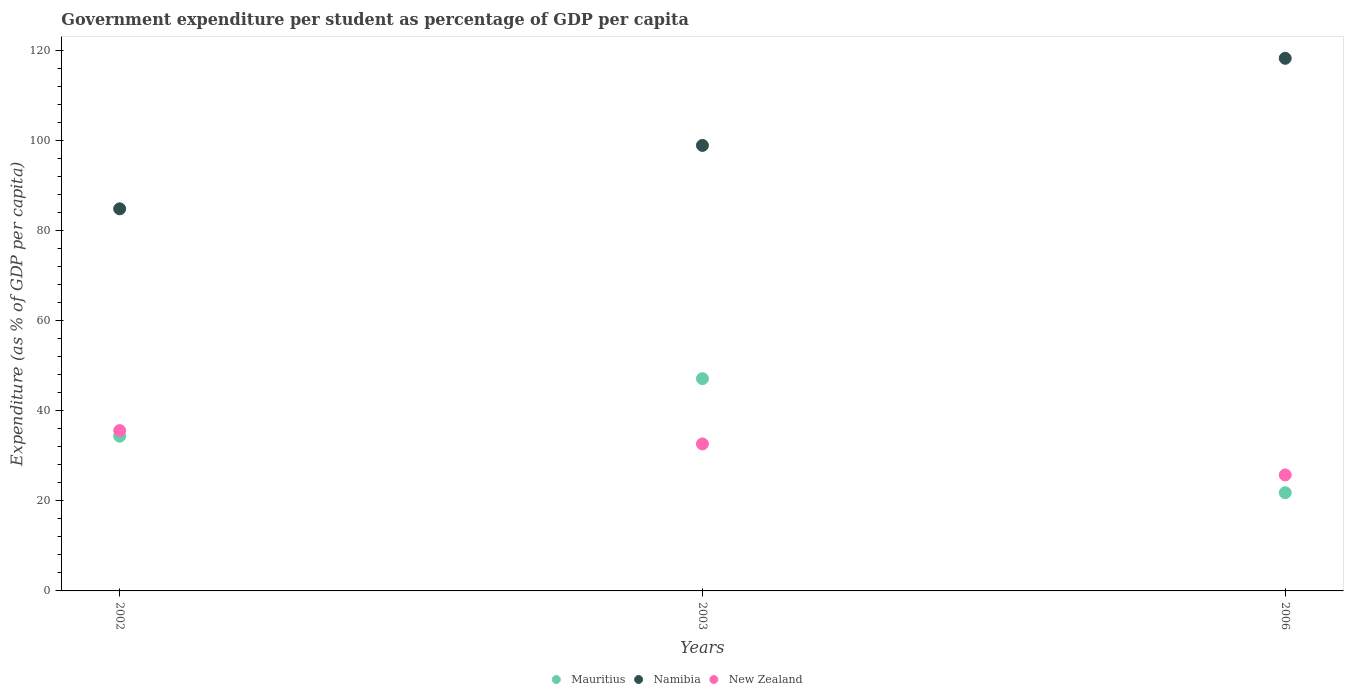How many different coloured dotlines are there?
Offer a terse response. 3. Is the number of dotlines equal to the number of legend labels?
Give a very brief answer. Yes. What is the percentage of expenditure per student in Mauritius in 2006?
Provide a succinct answer. 21.8. Across all years, what is the maximum percentage of expenditure per student in Namibia?
Give a very brief answer. 118.22. Across all years, what is the minimum percentage of expenditure per student in Namibia?
Your response must be concise. 84.81. In which year was the percentage of expenditure per student in Mauritius maximum?
Give a very brief answer. 2003. What is the total percentage of expenditure per student in New Zealand in the graph?
Make the answer very short. 93.96. What is the difference between the percentage of expenditure per student in New Zealand in 2003 and that in 2006?
Ensure brevity in your answer.  6.88. What is the difference between the percentage of expenditure per student in Mauritius in 2002 and the percentage of expenditure per student in Namibia in 2003?
Ensure brevity in your answer.  -64.53. What is the average percentage of expenditure per student in Mauritius per year?
Provide a succinct answer. 34.42. In the year 2003, what is the difference between the percentage of expenditure per student in New Zealand and percentage of expenditure per student in Mauritius?
Your answer should be compact. -14.48. In how many years, is the percentage of expenditure per student in Namibia greater than 44 %?
Make the answer very short. 3. What is the ratio of the percentage of expenditure per student in New Zealand in 2002 to that in 2006?
Make the answer very short. 1.38. Is the percentage of expenditure per student in Mauritius in 2002 less than that in 2003?
Your answer should be very brief. Yes. What is the difference between the highest and the second highest percentage of expenditure per student in Namibia?
Offer a terse response. 19.34. What is the difference between the highest and the lowest percentage of expenditure per student in Mauritius?
Offer a terse response. 25.31. In how many years, is the percentage of expenditure per student in Mauritius greater than the average percentage of expenditure per student in Mauritius taken over all years?
Your answer should be very brief. 1. Is the percentage of expenditure per student in New Zealand strictly greater than the percentage of expenditure per student in Mauritius over the years?
Give a very brief answer. No. Is the percentage of expenditure per student in Mauritius strictly less than the percentage of expenditure per student in Namibia over the years?
Ensure brevity in your answer.  Yes. How many dotlines are there?
Offer a very short reply. 3. How many years are there in the graph?
Offer a very short reply. 3. Does the graph contain any zero values?
Offer a very short reply. No. Does the graph contain grids?
Your answer should be very brief. No. Where does the legend appear in the graph?
Provide a short and direct response. Bottom center. How many legend labels are there?
Your answer should be compact. 3. How are the legend labels stacked?
Your answer should be compact. Horizontal. What is the title of the graph?
Your response must be concise. Government expenditure per student as percentage of GDP per capita. Does "Ukraine" appear as one of the legend labels in the graph?
Your response must be concise. No. What is the label or title of the Y-axis?
Provide a succinct answer. Expenditure (as % of GDP per capita). What is the Expenditure (as % of GDP per capita) of Mauritius in 2002?
Your answer should be compact. 34.35. What is the Expenditure (as % of GDP per capita) in Namibia in 2002?
Offer a very short reply. 84.81. What is the Expenditure (as % of GDP per capita) of New Zealand in 2002?
Give a very brief answer. 35.58. What is the Expenditure (as % of GDP per capita) of Mauritius in 2003?
Give a very brief answer. 47.11. What is the Expenditure (as % of GDP per capita) in Namibia in 2003?
Offer a terse response. 98.88. What is the Expenditure (as % of GDP per capita) in New Zealand in 2003?
Offer a terse response. 32.63. What is the Expenditure (as % of GDP per capita) of Mauritius in 2006?
Offer a terse response. 21.8. What is the Expenditure (as % of GDP per capita) of Namibia in 2006?
Your response must be concise. 118.22. What is the Expenditure (as % of GDP per capita) of New Zealand in 2006?
Ensure brevity in your answer.  25.75. Across all years, what is the maximum Expenditure (as % of GDP per capita) of Mauritius?
Offer a terse response. 47.11. Across all years, what is the maximum Expenditure (as % of GDP per capita) in Namibia?
Keep it short and to the point. 118.22. Across all years, what is the maximum Expenditure (as % of GDP per capita) in New Zealand?
Your answer should be compact. 35.58. Across all years, what is the minimum Expenditure (as % of GDP per capita) of Mauritius?
Provide a succinct answer. 21.8. Across all years, what is the minimum Expenditure (as % of GDP per capita) of Namibia?
Offer a terse response. 84.81. Across all years, what is the minimum Expenditure (as % of GDP per capita) in New Zealand?
Your answer should be very brief. 25.75. What is the total Expenditure (as % of GDP per capita) in Mauritius in the graph?
Keep it short and to the point. 103.26. What is the total Expenditure (as % of GDP per capita) in Namibia in the graph?
Offer a very short reply. 301.9. What is the total Expenditure (as % of GDP per capita) of New Zealand in the graph?
Provide a short and direct response. 93.96. What is the difference between the Expenditure (as % of GDP per capita) in Mauritius in 2002 and that in 2003?
Your response must be concise. -12.76. What is the difference between the Expenditure (as % of GDP per capita) in Namibia in 2002 and that in 2003?
Make the answer very short. -14.07. What is the difference between the Expenditure (as % of GDP per capita) in New Zealand in 2002 and that in 2003?
Make the answer very short. 2.96. What is the difference between the Expenditure (as % of GDP per capita) in Mauritius in 2002 and that in 2006?
Offer a very short reply. 12.55. What is the difference between the Expenditure (as % of GDP per capita) in Namibia in 2002 and that in 2006?
Offer a very short reply. -33.41. What is the difference between the Expenditure (as % of GDP per capita) in New Zealand in 2002 and that in 2006?
Offer a very short reply. 9.84. What is the difference between the Expenditure (as % of GDP per capita) in Mauritius in 2003 and that in 2006?
Your answer should be compact. 25.31. What is the difference between the Expenditure (as % of GDP per capita) of Namibia in 2003 and that in 2006?
Keep it short and to the point. -19.34. What is the difference between the Expenditure (as % of GDP per capita) in New Zealand in 2003 and that in 2006?
Your response must be concise. 6.88. What is the difference between the Expenditure (as % of GDP per capita) in Mauritius in 2002 and the Expenditure (as % of GDP per capita) in Namibia in 2003?
Provide a succinct answer. -64.53. What is the difference between the Expenditure (as % of GDP per capita) in Mauritius in 2002 and the Expenditure (as % of GDP per capita) in New Zealand in 2003?
Give a very brief answer. 1.72. What is the difference between the Expenditure (as % of GDP per capita) in Namibia in 2002 and the Expenditure (as % of GDP per capita) in New Zealand in 2003?
Keep it short and to the point. 52.18. What is the difference between the Expenditure (as % of GDP per capita) of Mauritius in 2002 and the Expenditure (as % of GDP per capita) of Namibia in 2006?
Offer a terse response. -83.87. What is the difference between the Expenditure (as % of GDP per capita) in Mauritius in 2002 and the Expenditure (as % of GDP per capita) in New Zealand in 2006?
Ensure brevity in your answer.  8.6. What is the difference between the Expenditure (as % of GDP per capita) in Namibia in 2002 and the Expenditure (as % of GDP per capita) in New Zealand in 2006?
Offer a terse response. 59.06. What is the difference between the Expenditure (as % of GDP per capita) in Mauritius in 2003 and the Expenditure (as % of GDP per capita) in Namibia in 2006?
Offer a very short reply. -71.11. What is the difference between the Expenditure (as % of GDP per capita) in Mauritius in 2003 and the Expenditure (as % of GDP per capita) in New Zealand in 2006?
Provide a succinct answer. 21.36. What is the difference between the Expenditure (as % of GDP per capita) of Namibia in 2003 and the Expenditure (as % of GDP per capita) of New Zealand in 2006?
Offer a very short reply. 73.13. What is the average Expenditure (as % of GDP per capita) in Mauritius per year?
Provide a short and direct response. 34.42. What is the average Expenditure (as % of GDP per capita) in Namibia per year?
Offer a very short reply. 100.63. What is the average Expenditure (as % of GDP per capita) of New Zealand per year?
Keep it short and to the point. 31.32. In the year 2002, what is the difference between the Expenditure (as % of GDP per capita) of Mauritius and Expenditure (as % of GDP per capita) of Namibia?
Provide a short and direct response. -50.46. In the year 2002, what is the difference between the Expenditure (as % of GDP per capita) of Mauritius and Expenditure (as % of GDP per capita) of New Zealand?
Your answer should be very brief. -1.23. In the year 2002, what is the difference between the Expenditure (as % of GDP per capita) of Namibia and Expenditure (as % of GDP per capita) of New Zealand?
Provide a short and direct response. 49.23. In the year 2003, what is the difference between the Expenditure (as % of GDP per capita) in Mauritius and Expenditure (as % of GDP per capita) in Namibia?
Provide a succinct answer. -51.77. In the year 2003, what is the difference between the Expenditure (as % of GDP per capita) of Mauritius and Expenditure (as % of GDP per capita) of New Zealand?
Your answer should be compact. 14.48. In the year 2003, what is the difference between the Expenditure (as % of GDP per capita) of Namibia and Expenditure (as % of GDP per capita) of New Zealand?
Offer a terse response. 66.25. In the year 2006, what is the difference between the Expenditure (as % of GDP per capita) in Mauritius and Expenditure (as % of GDP per capita) in Namibia?
Provide a succinct answer. -96.42. In the year 2006, what is the difference between the Expenditure (as % of GDP per capita) in Mauritius and Expenditure (as % of GDP per capita) in New Zealand?
Offer a terse response. -3.95. In the year 2006, what is the difference between the Expenditure (as % of GDP per capita) in Namibia and Expenditure (as % of GDP per capita) in New Zealand?
Provide a short and direct response. 92.47. What is the ratio of the Expenditure (as % of GDP per capita) of Mauritius in 2002 to that in 2003?
Offer a terse response. 0.73. What is the ratio of the Expenditure (as % of GDP per capita) of Namibia in 2002 to that in 2003?
Keep it short and to the point. 0.86. What is the ratio of the Expenditure (as % of GDP per capita) in New Zealand in 2002 to that in 2003?
Provide a succinct answer. 1.09. What is the ratio of the Expenditure (as % of GDP per capita) of Mauritius in 2002 to that in 2006?
Provide a succinct answer. 1.58. What is the ratio of the Expenditure (as % of GDP per capita) of Namibia in 2002 to that in 2006?
Offer a terse response. 0.72. What is the ratio of the Expenditure (as % of GDP per capita) in New Zealand in 2002 to that in 2006?
Offer a terse response. 1.38. What is the ratio of the Expenditure (as % of GDP per capita) of Mauritius in 2003 to that in 2006?
Keep it short and to the point. 2.16. What is the ratio of the Expenditure (as % of GDP per capita) of Namibia in 2003 to that in 2006?
Give a very brief answer. 0.84. What is the ratio of the Expenditure (as % of GDP per capita) of New Zealand in 2003 to that in 2006?
Your answer should be very brief. 1.27. What is the difference between the highest and the second highest Expenditure (as % of GDP per capita) in Mauritius?
Give a very brief answer. 12.76. What is the difference between the highest and the second highest Expenditure (as % of GDP per capita) of Namibia?
Keep it short and to the point. 19.34. What is the difference between the highest and the second highest Expenditure (as % of GDP per capita) in New Zealand?
Give a very brief answer. 2.96. What is the difference between the highest and the lowest Expenditure (as % of GDP per capita) of Mauritius?
Offer a very short reply. 25.31. What is the difference between the highest and the lowest Expenditure (as % of GDP per capita) of Namibia?
Your response must be concise. 33.41. What is the difference between the highest and the lowest Expenditure (as % of GDP per capita) of New Zealand?
Your answer should be very brief. 9.84. 